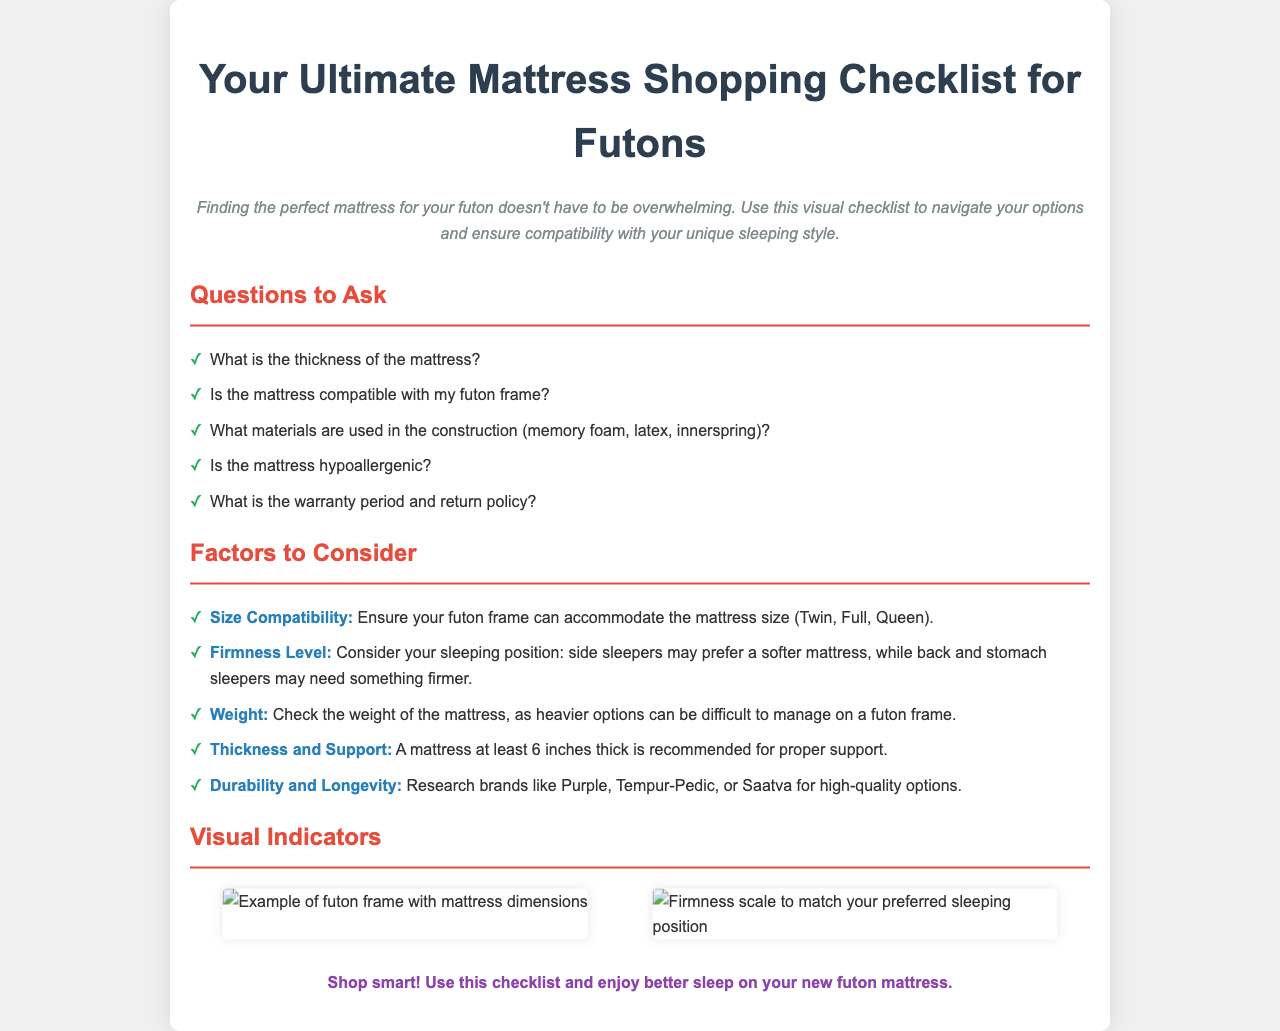What is the title of the document? The title is prominently displayed at the top of the document.
Answer: Your Ultimate Mattress Shopping Checklist for Futons How many questions are listed to ask when shopping for a mattress? The number of items in the "Questions to Ask" section indicates the total.
Answer: Five What factors should be considered for futon compatibility? The main list of factors in the document provides this information.
Answer: Size Compatibility, Firmness Level, Weight, Thickness and Support, Durability and Longevity What is the recommended thickness for a mattress for proper support? The document explicitly states this as part of the recommended considerations.
Answer: Six inches Which brands are mentioned for high-quality options? The document lists specific brands that are highlighted for their quality.
Answer: Purple, Tempur-Pedic, Saatva What color is used for headings in the "Factors to Consider" section? The document uses a specific color to emphasize section headings.
Answer: Red What type of mattress material is mentioned in the checklist? The examples of materials are clearly listed in the questions to ask.
Answer: Memory foam, latex, innerspring What is the visual content in the checklist meant to illustrate? The visual section contains images meant to represent specific information.
Answer: Mattress dimensions and firmness scale 